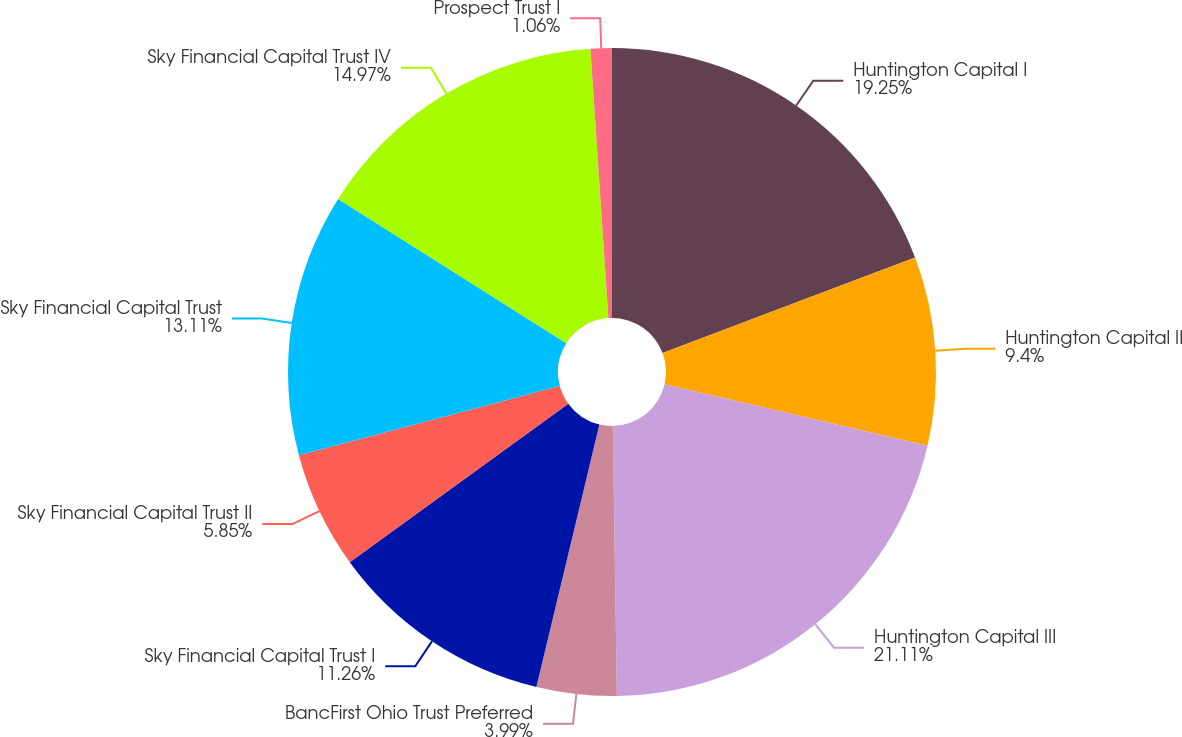<chart> <loc_0><loc_0><loc_500><loc_500><pie_chart><fcel>Huntington Capital I<fcel>Huntington Capital II<fcel>Huntington Capital III<fcel>BancFirst Ohio Trust Preferred<fcel>Sky Financial Capital Trust I<fcel>Sky Financial Capital Trust II<fcel>Sky Financial Capital Trust<fcel>Sky Financial Capital Trust IV<fcel>Prospect Trust I<nl><fcel>19.25%<fcel>9.4%<fcel>21.11%<fcel>3.99%<fcel>11.26%<fcel>5.85%<fcel>13.11%<fcel>14.97%<fcel>1.06%<nl></chart> 